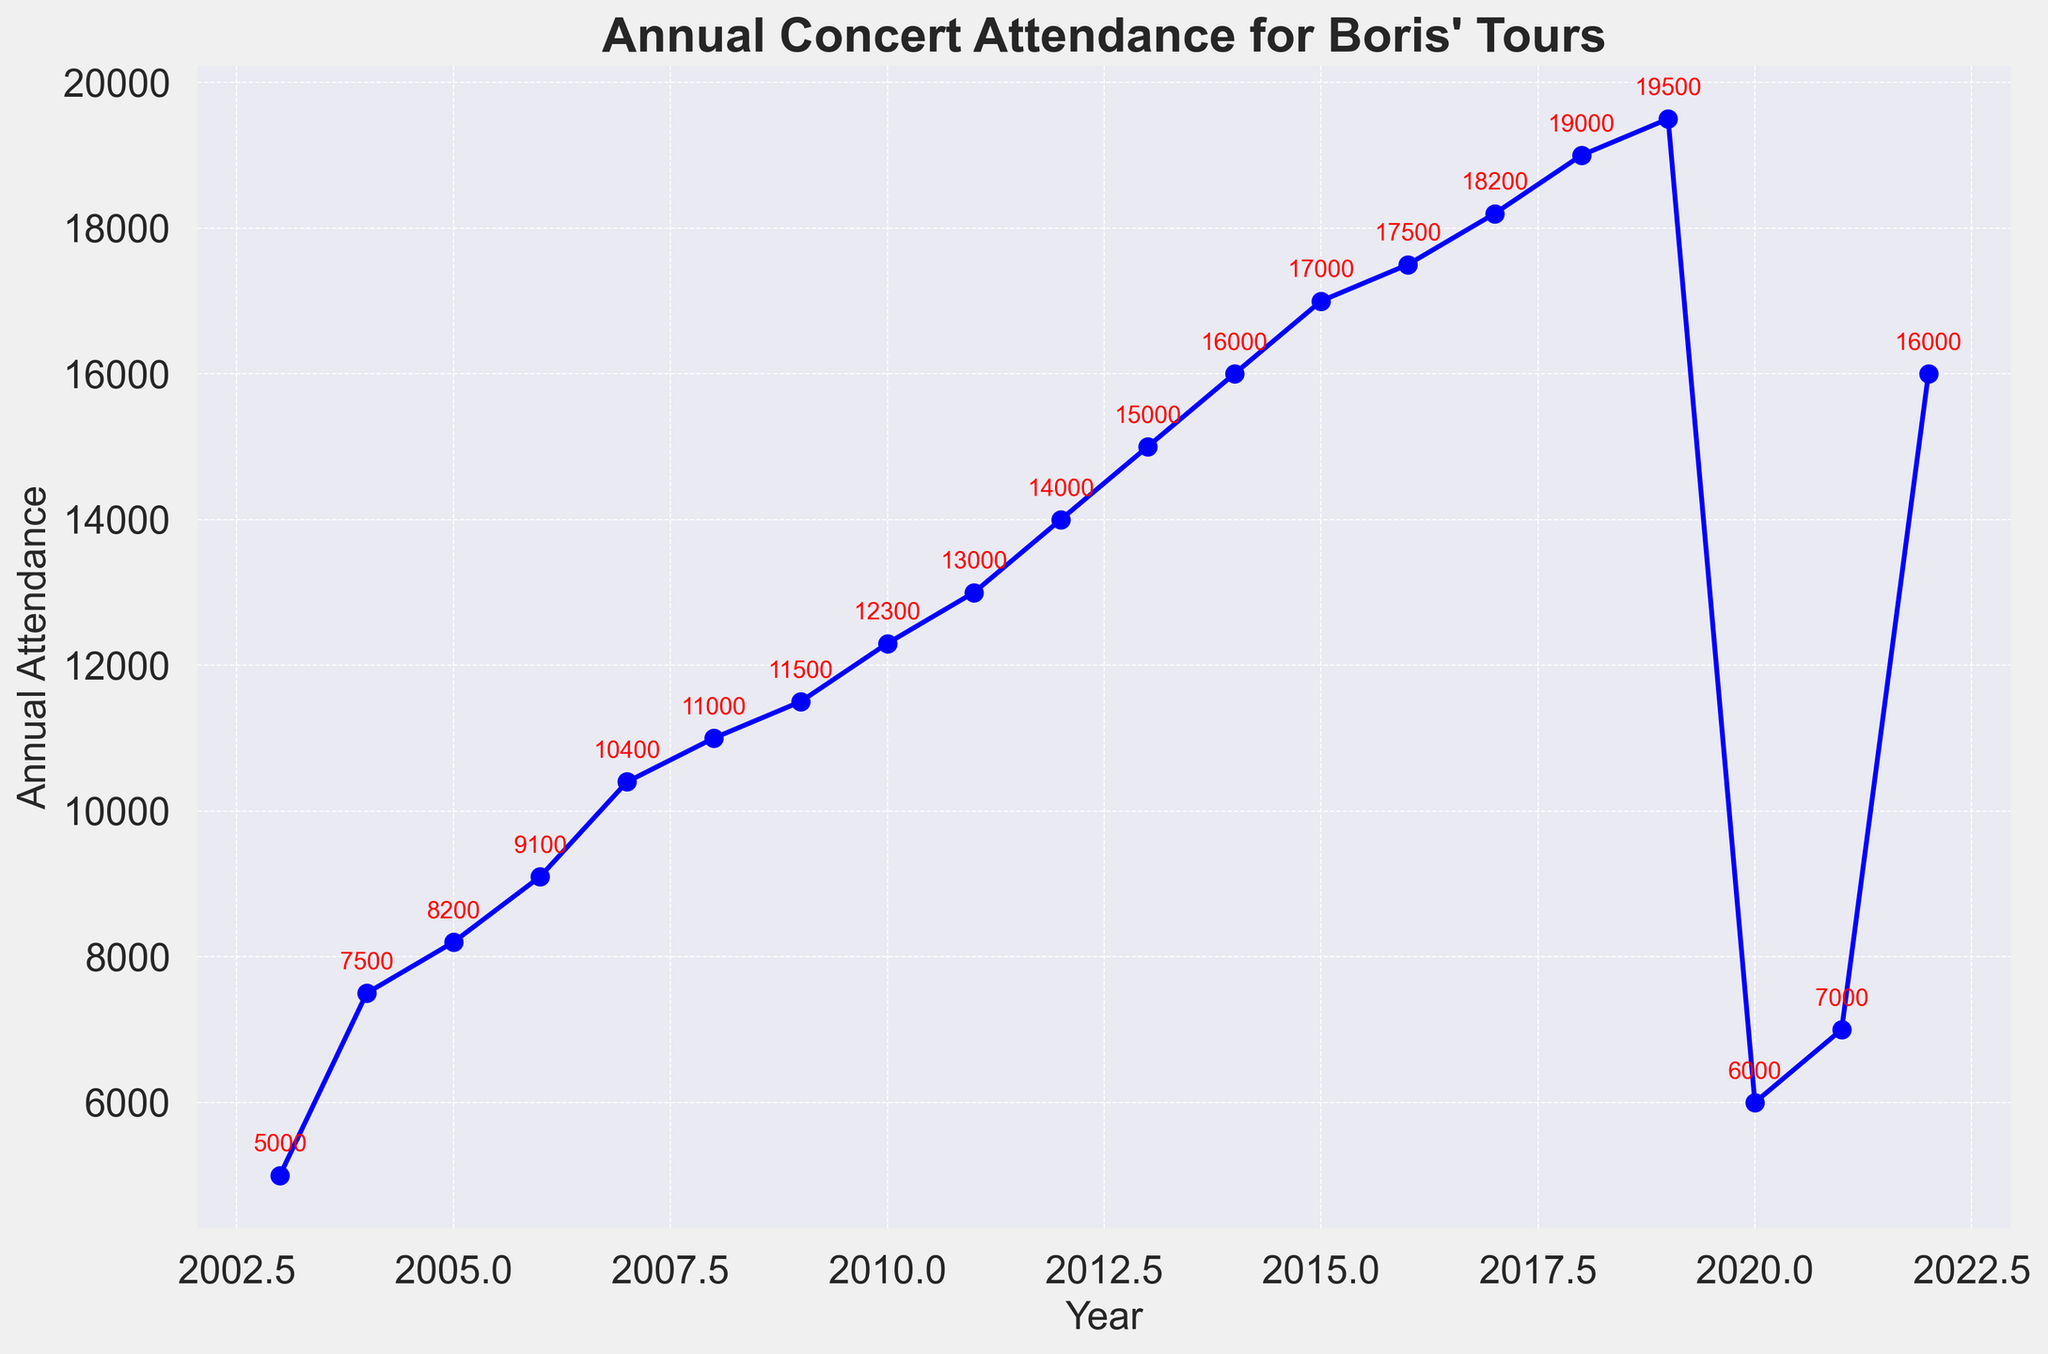Which year had the highest annual attendance? The highest annual attendance can be identified by looking at the peak point on the line chart. In this case, it is in 2019 with an attendance of 19,500.
Answer: 2019 What is the total attendance from 2003 to 2019? To find the total attendance from 2003 to 2019, add the attendance values for each year within the given range: 5000 + 7500 + 8200 + 9100 + 10400 + 11000 + 11500 + 12300 + 13000 + 14000 + 15000 + 16000 + 17000 + 17500 + 18200 + 19000 + 19500 = 233,200.
Answer: 233,200 How did the attendance in 2020 compare to 2019? To compare the attendance in 2020 and 2019, subtract the 2020 value from the 2019 value. Attendance in 2020 was 6,000, and in 2019 it was 19,500. The difference is 19,500 - 6,000 = 13,500.
Answer: 13,500 less Which two consecutive years show the largest increase in attendance? To find the largest increase, calculate the difference between consecutive years and compare them. The largest increase occurs between 2011 and 2012, where the attendance increased from 13,000 to 14,000, an increase of 1,000.
Answer: 2011-2012 What was the average attendance from 2020 to 2022? To find the average attendance from 2020 to 2022, sum the attendance values for these years and divide by the number of years. (6,000 + 7,000 + 16,000) / 3 = 9,666.67
Answer: 9,666.67 By how much did the attendance grow from 2003 to 2019? Subtract the attendance in 2003 from the attendance in 2019. So, it is 19,500 (2019) - 5,000 (2003) = 14,500.
Answer: 14,500 Which year between 2003 and 2019 saw the smallest increase in attendance from the previous year? Calculate the difference in attendance for each year compared to the previous year. The smallest increase is from 2008 to 2009, where the attendance increased by 500 (11,000 - 10,500).
Answer: 2008-2009 What is the visual color of the line representing the attendance data in the chart? The line representing the attendance data in the chart is drawn in blue color, as indicated by its visual attributes.
Answer: blue Determine the overall trend of the annual attendance from 2003 to 2022, notice any notable fluctuations. The overall trend from 2003 to 2022 shows a steady increase in attendance until 2019, followed by a sharp decline in 2020, a slight recovery in 2021, and a significant recovery in 2022.
Answer: Steady increase till 2019, sharp decline in 2020, recovery after What is the total attendance for the years 2020, 2021, and 2022 combined? To find the total attendance for 2020, 2021, and 2022, add the values for these years: 6,000 + 7,000 + 16,000 = 29,000.
Answer: 29,000 